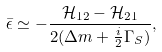Convert formula to latex. <formula><loc_0><loc_0><loc_500><loc_500>\bar { \epsilon } \simeq - \frac { \mathcal { H } _ { 1 2 } - \mathcal { H } _ { 2 1 } } { 2 ( \Delta m + \frac { i } { 2 } \Gamma _ { S } ) } ,</formula> 